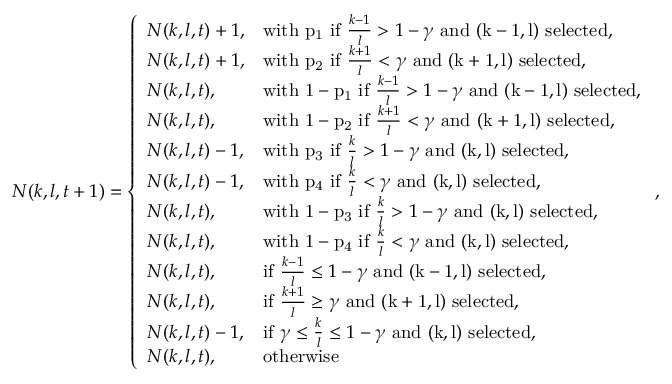<formula> <loc_0><loc_0><loc_500><loc_500>N ( k , l , t + 1 ) = \left \{ \begin{array} { l l } { N ( k , l , t ) + 1 , } & { w i t h p _ { 1 } i f \frac { k - 1 } { l } > 1 - \gamma a n d ( k - 1 , l ) s e l e c t e d , } \\ { N ( k , l , t ) + 1 , } & { w i t h p _ { 2 } i f \frac { k + 1 } { l } < \gamma a n d ( k + 1 , l ) s e l e c t e d , } \\ { N ( k , l , t ) , } & { w i t h 1 - p _ { 1 } i f \frac { k - 1 } { l } > 1 - \gamma a n d ( k - 1 , l ) s e l e c t e d , } \\ { N ( k , l , t ) , } & { w i t h 1 - p _ { 2 } i f \frac { k + 1 } { l } < \gamma a n d ( k + 1 , l ) s e l e c t e d , } \\ { N ( k , l , t ) - 1 , } & { w i t h p _ { 3 } i f \frac { k } { l } > 1 - \gamma a n d ( k , l ) s e l e c t e d , } \\ { N ( k , l , t ) - 1 , } & { w i t h p _ { 4 } i f \frac { k } { l } < \gamma a n d ( k , l ) s e l e c t e d , } \\ { N ( k , l , t ) , } & { w i t h 1 - p _ { 3 } i f \frac { k } { l } > 1 - \gamma a n d ( k , l ) s e l e c t e d , } \\ { N ( k , l , t ) , } & { w i t h 1 - p _ { 4 } i f \frac { k } { l } < \gamma a n d ( k , l ) s e l e c t e d , } \\ { N ( k , l , t ) , } & { i f \frac { k - 1 } { l } \leq 1 - \gamma a n d ( k - 1 , l ) s e l e c t e d , } \\ { N ( k , l , t ) , } & { i f \frac { k + 1 } { l } \geq \gamma a n d ( k + 1 , l ) s e l e c t e d , } \\ { N ( k , l , t ) - 1 , } & { i f \gamma \leq \frac { k } { l } \leq 1 - \gamma a n d ( k , l ) s e l e c t e d , } \\ { N ( k , l , t ) , } & { o t h e r w i s e } \end{array} ,</formula> 